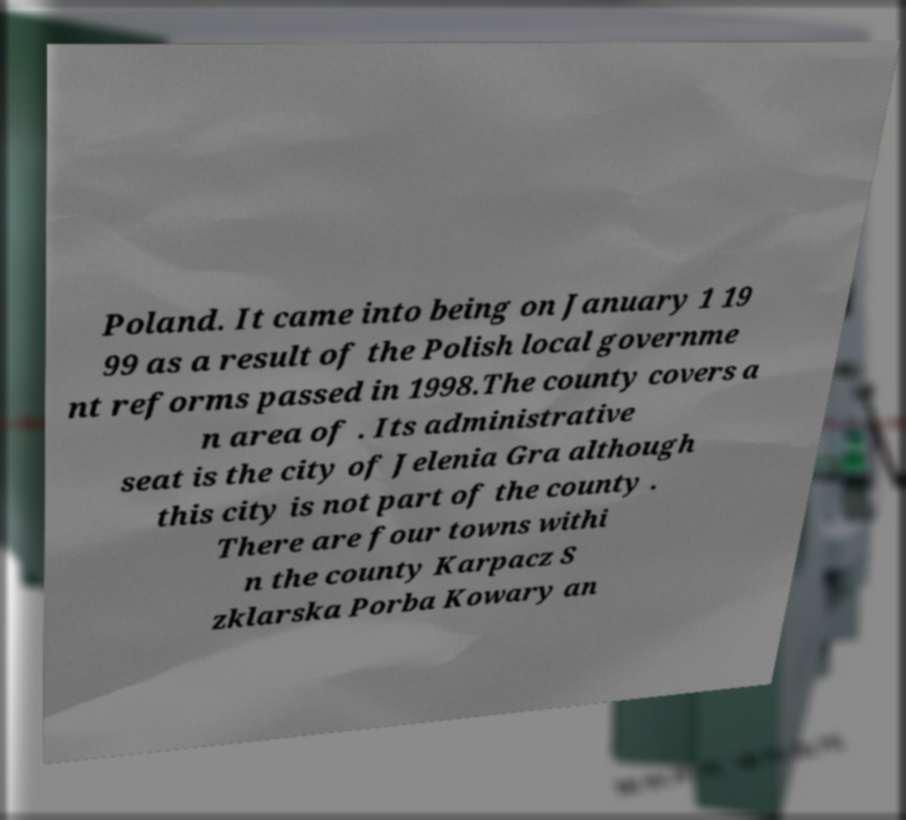What messages or text are displayed in this image? I need them in a readable, typed format. Poland. It came into being on January 1 19 99 as a result of the Polish local governme nt reforms passed in 1998.The county covers a n area of . Its administrative seat is the city of Jelenia Gra although this city is not part of the county . There are four towns withi n the county Karpacz S zklarska Porba Kowary an 